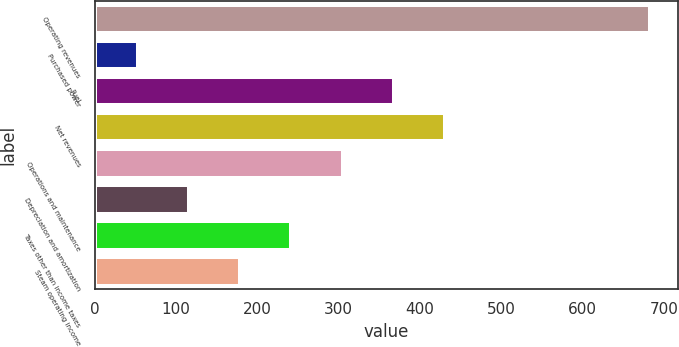<chart> <loc_0><loc_0><loc_500><loc_500><bar_chart><fcel>Operating revenues<fcel>Purchased power<fcel>Fuel<fcel>Net revenues<fcel>Operations and maintenance<fcel>Depreciation and amortization<fcel>Taxes other than income taxes<fcel>Steam operating income<nl><fcel>683<fcel>53<fcel>368<fcel>431<fcel>305<fcel>116<fcel>242<fcel>179<nl></chart> 